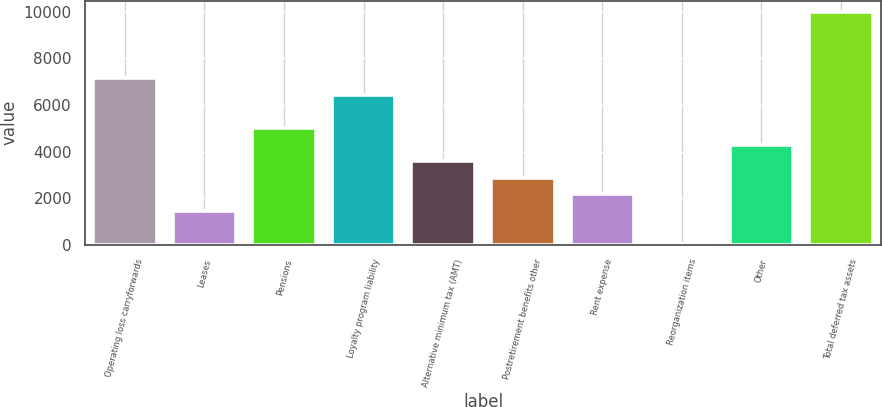Convert chart. <chart><loc_0><loc_0><loc_500><loc_500><bar_chart><fcel>Operating loss carryforwards<fcel>Leases<fcel>Pensions<fcel>Loyalty program liability<fcel>Alternative minimum tax (AMT)<fcel>Postretirement benefits other<fcel>Rent expense<fcel>Reorganization items<fcel>Other<fcel>Total deferred tax assets<nl><fcel>7143<fcel>1456.6<fcel>5010.6<fcel>6432.2<fcel>3589<fcel>2878.2<fcel>2167.4<fcel>35<fcel>4299.8<fcel>9986.2<nl></chart> 